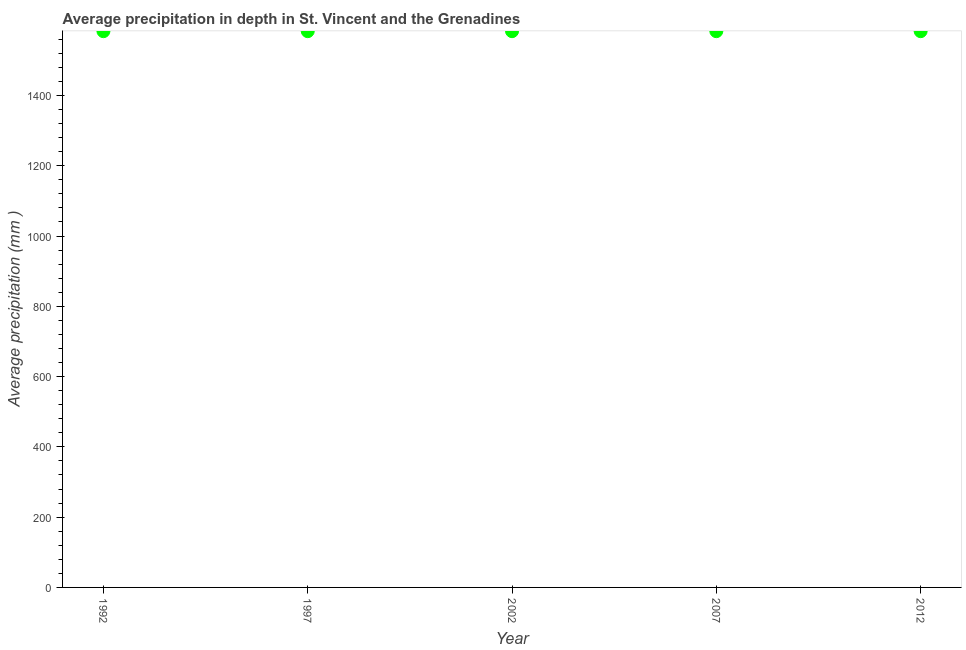What is the average precipitation in depth in 2002?
Make the answer very short. 1583. Across all years, what is the maximum average precipitation in depth?
Offer a terse response. 1583. Across all years, what is the minimum average precipitation in depth?
Make the answer very short. 1583. What is the sum of the average precipitation in depth?
Make the answer very short. 7915. What is the difference between the average precipitation in depth in 2002 and 2012?
Offer a very short reply. 0. What is the average average precipitation in depth per year?
Offer a very short reply. 1583. What is the median average precipitation in depth?
Ensure brevity in your answer.  1583. In how many years, is the average precipitation in depth greater than 1240 mm?
Your answer should be very brief. 5. Do a majority of the years between 2012 and 1997 (inclusive) have average precipitation in depth greater than 1120 mm?
Keep it short and to the point. Yes. What is the ratio of the average precipitation in depth in 2002 to that in 2012?
Offer a very short reply. 1. Is the average precipitation in depth in 1997 less than that in 2007?
Ensure brevity in your answer.  No. Is the sum of the average precipitation in depth in 2002 and 2012 greater than the maximum average precipitation in depth across all years?
Provide a succinct answer. Yes. What is the difference between two consecutive major ticks on the Y-axis?
Keep it short and to the point. 200. Are the values on the major ticks of Y-axis written in scientific E-notation?
Provide a short and direct response. No. What is the title of the graph?
Make the answer very short. Average precipitation in depth in St. Vincent and the Grenadines. What is the label or title of the X-axis?
Offer a terse response. Year. What is the label or title of the Y-axis?
Give a very brief answer. Average precipitation (mm ). What is the Average precipitation (mm ) in 1992?
Your response must be concise. 1583. What is the Average precipitation (mm ) in 1997?
Give a very brief answer. 1583. What is the Average precipitation (mm ) in 2002?
Provide a short and direct response. 1583. What is the Average precipitation (mm ) in 2007?
Keep it short and to the point. 1583. What is the Average precipitation (mm ) in 2012?
Offer a terse response. 1583. What is the difference between the Average precipitation (mm ) in 1992 and 1997?
Give a very brief answer. 0. What is the difference between the Average precipitation (mm ) in 1992 and 2007?
Provide a succinct answer. 0. What is the difference between the Average precipitation (mm ) in 1992 and 2012?
Your response must be concise. 0. What is the difference between the Average precipitation (mm ) in 2002 and 2012?
Your answer should be compact. 0. What is the difference between the Average precipitation (mm ) in 2007 and 2012?
Your response must be concise. 0. What is the ratio of the Average precipitation (mm ) in 1992 to that in 1997?
Give a very brief answer. 1. What is the ratio of the Average precipitation (mm ) in 1992 to that in 2002?
Ensure brevity in your answer.  1. What is the ratio of the Average precipitation (mm ) in 1992 to that in 2007?
Make the answer very short. 1. What is the ratio of the Average precipitation (mm ) in 1992 to that in 2012?
Your response must be concise. 1. What is the ratio of the Average precipitation (mm ) in 1997 to that in 2007?
Make the answer very short. 1. What is the ratio of the Average precipitation (mm ) in 2002 to that in 2012?
Your answer should be very brief. 1. 